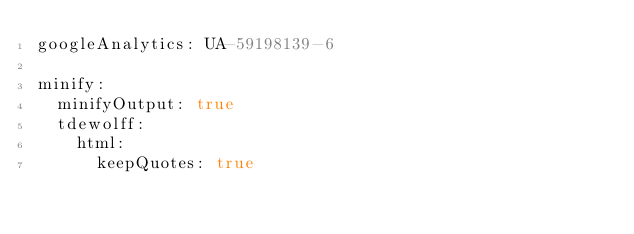Convert code to text. <code><loc_0><loc_0><loc_500><loc_500><_YAML_>googleAnalytics: UA-59198139-6

minify:
  minifyOutput: true
  tdewolff:
    html:
      keepQuotes: true</code> 